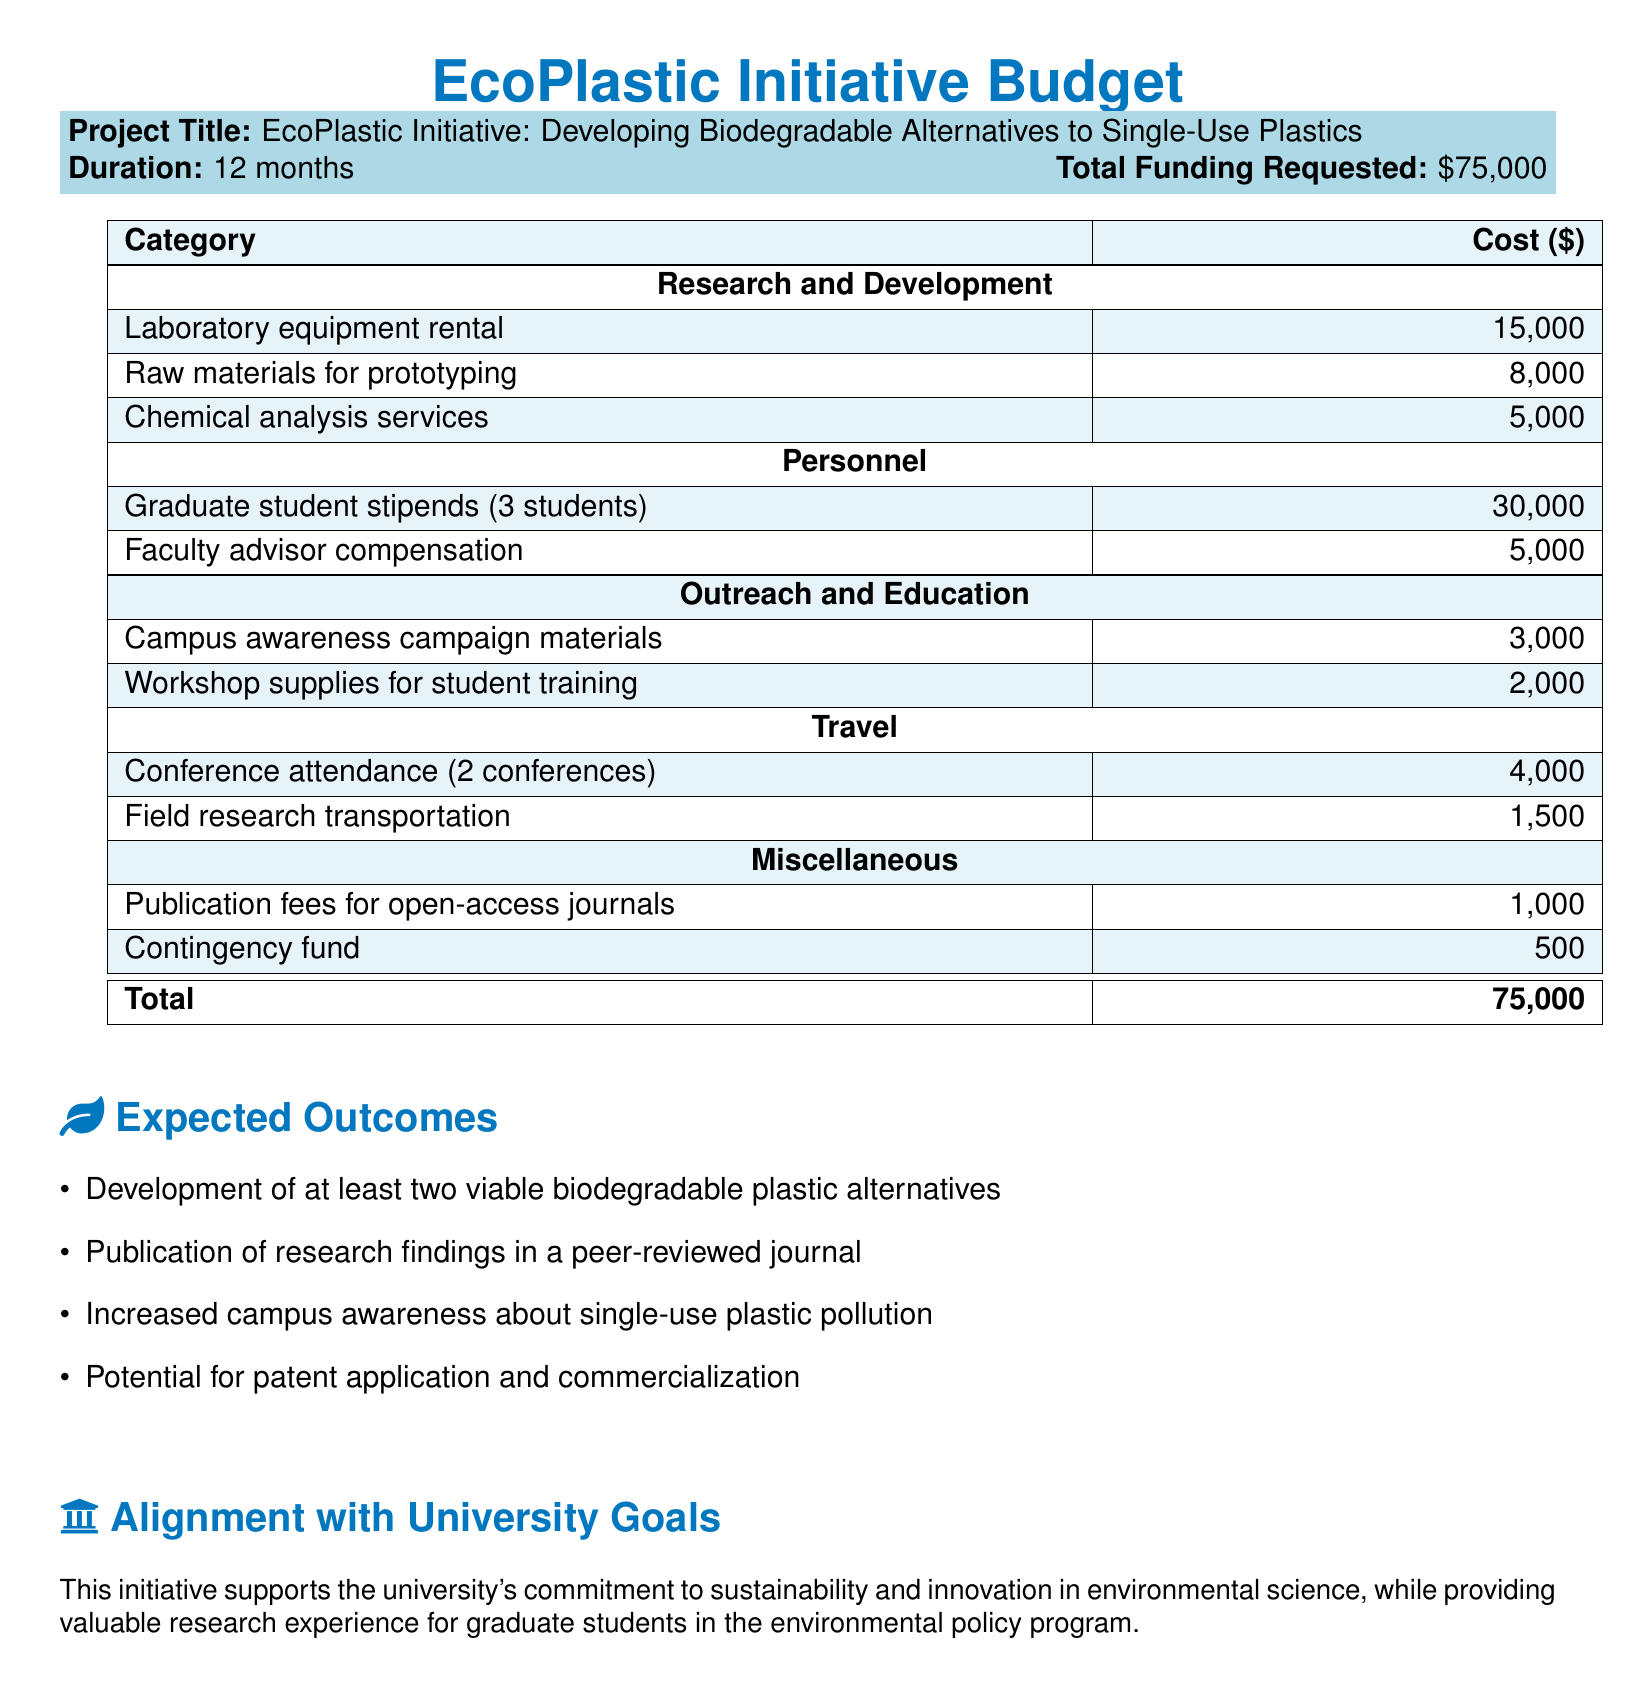What is the project title? The project title is mentioned at the beginning of the document as "EcoPlastic Initiative: Developing Biodegradable Alternatives to Single-Use Plastics."
Answer: EcoPlastic Initiative: Developing Biodegradable Alternatives to Single-Use Plastics How much funding is requested for the initiative? The total funding requested is clearly stated in the document under the funding section.
Answer: $75,000 What is the duration of the project? The duration is specified in the project details section of the document.
Answer: 12 months How much is allocated for graduate student stipends? The specific amount for graduate student stipends is outlined under the personnel category.
Answer: $30,000 How many biodegradable plastic alternatives are expected to be developed? The expected outcome specifies the number of biodegradable alternatives to be developed in the initiative.
Answer: two What type of campaign is part of the outreach and education efforts? The document mentions a specific type of campaign that is part of the outreach strategy.
Answer: Campus awareness campaign What is one of the expected outcomes of the project? The expected outcomes section lists multiple expected outcomes, and one can be easily identified.
Answer: Development of at least two viable biodegradable plastic alternatives Which section mentions the faculty advisor's compensation? The personnel section specifies the compensation for the faculty advisor, which is an aspect of the budget.
Answer: Personnel What is included in the miscellaneous category? The miscellaneous category of the budget outlines specific items and their costs.
Answer: Publication fees for open-access journals 